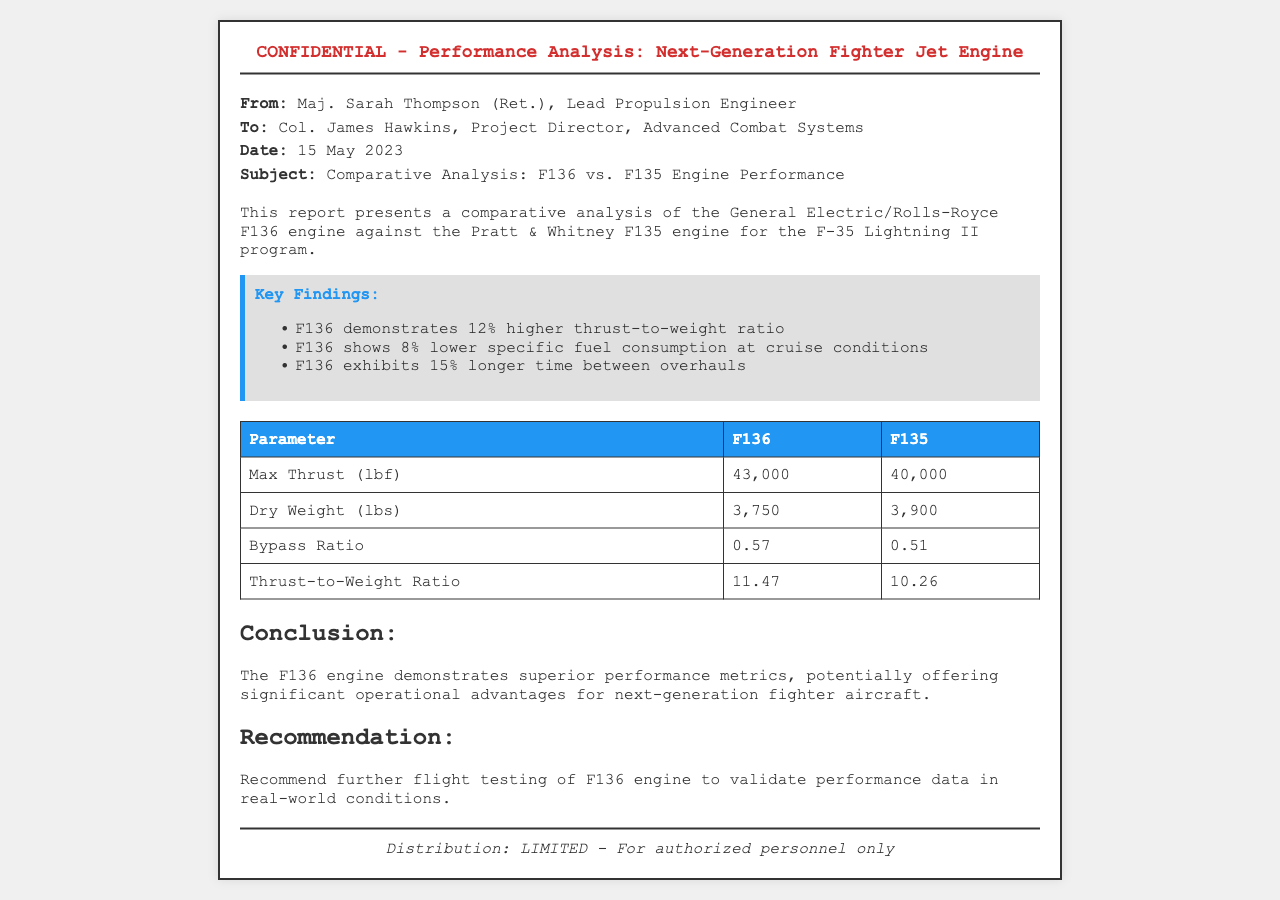what is the date of the report? The date of the report is mentioned in the meta-info section, specifically as May 15, 2023.
Answer: May 15, 2023 who is the sender of the report? The sender of the report is indicated in the meta-info section as Maj. Sarah Thompson.
Answer: Maj. Sarah Thompson what is the thrust-to-weight ratio of the F136 engine? The thrust-to-weight ratio for the F136 engine is listed in the comparative table under "Thrust-to-Weight Ratio."
Answer: 11.47 how much lower is the specific fuel consumption of the F136 compared to the F135? The report states that the F136 shows 8% lower specific fuel consumption, which is captured in the key findings.
Answer: 8% what is the recommendation given in the report? The recommendation is presented in a specific section and states to further flight test the F136 engine.
Answer: Further flight testing of F136 engine which engine has a higher max thrust? The comparative table provides the max thrust values that allow for determining which engine has a higher thrust.
Answer: F136 what is the max thrust of the F135 engine? The max thrust value for the F135 engine is directly mentioned in the data table section of the document.
Answer: 40,000 what is the conclusion drawn in the report? The conclusion summarizes the findings and describes the performance metrics of the F136 engine in relation to operational advantages.
Answer: Superior performance metrics what type of document is this? The structure of the document indicates it is a fax, specifically a confidential report on engine performance analysis.
Answer: Fax 